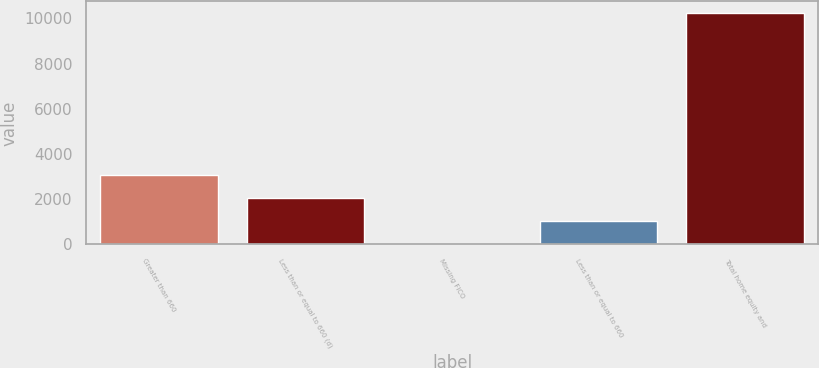Convert chart to OTSL. <chart><loc_0><loc_0><loc_500><loc_500><bar_chart><fcel>Greater than 660<fcel>Less than or equal to 660 (d)<fcel>Missing FICO<fcel>Less than or equal to 660<fcel>Total home equity and<nl><fcel>3086<fcel>2064<fcel>20<fcel>1042<fcel>10240<nl></chart> 